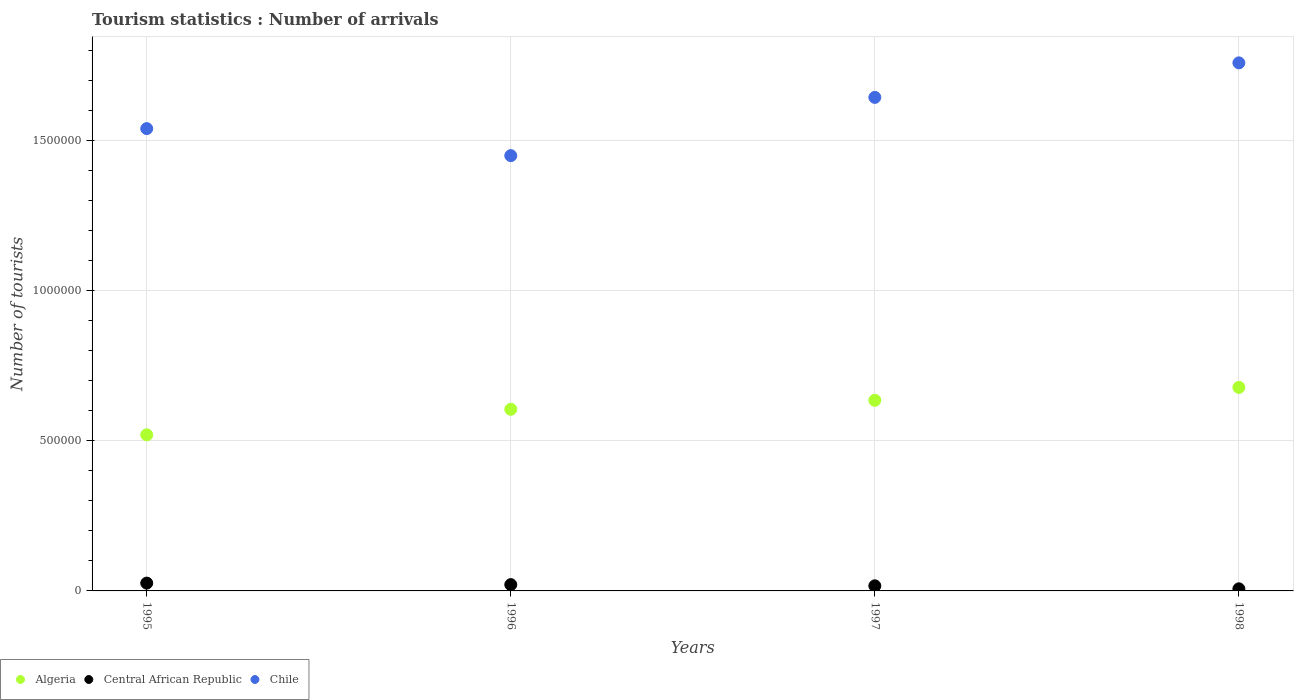What is the number of tourist arrivals in Algeria in 1996?
Make the answer very short. 6.05e+05. Across all years, what is the maximum number of tourist arrivals in Algeria?
Make the answer very short. 6.78e+05. Across all years, what is the minimum number of tourist arrivals in Central African Republic?
Offer a terse response. 7000. In which year was the number of tourist arrivals in Algeria minimum?
Your answer should be very brief. 1995. What is the total number of tourist arrivals in Central African Republic in the graph?
Offer a terse response. 7.10e+04. What is the difference between the number of tourist arrivals in Chile in 1996 and that in 1997?
Your answer should be very brief. -1.94e+05. What is the difference between the number of tourist arrivals in Chile in 1997 and the number of tourist arrivals in Central African Republic in 1996?
Your response must be concise. 1.62e+06. What is the average number of tourist arrivals in Algeria per year?
Your answer should be very brief. 6.10e+05. In the year 1995, what is the difference between the number of tourist arrivals in Chile and number of tourist arrivals in Algeria?
Your answer should be compact. 1.02e+06. In how many years, is the number of tourist arrivals in Chile greater than 600000?
Offer a very short reply. 4. What is the ratio of the number of tourist arrivals in Central African Republic in 1996 to that in 1998?
Provide a short and direct response. 3. Is the difference between the number of tourist arrivals in Chile in 1995 and 1996 greater than the difference between the number of tourist arrivals in Algeria in 1995 and 1996?
Keep it short and to the point. Yes. What is the difference between the highest and the second highest number of tourist arrivals in Chile?
Ensure brevity in your answer.  1.15e+05. What is the difference between the highest and the lowest number of tourist arrivals in Chile?
Give a very brief answer. 3.09e+05. Is the sum of the number of tourist arrivals in Algeria in 1997 and 1998 greater than the maximum number of tourist arrivals in Central African Republic across all years?
Ensure brevity in your answer.  Yes. Is it the case that in every year, the sum of the number of tourist arrivals in Central African Republic and number of tourist arrivals in Algeria  is greater than the number of tourist arrivals in Chile?
Your answer should be very brief. No. Does the number of tourist arrivals in Central African Republic monotonically increase over the years?
Your answer should be very brief. No. How many years are there in the graph?
Make the answer very short. 4. What is the difference between two consecutive major ticks on the Y-axis?
Offer a terse response. 5.00e+05. Does the graph contain grids?
Provide a succinct answer. Yes. Where does the legend appear in the graph?
Offer a terse response. Bottom left. What is the title of the graph?
Provide a succinct answer. Tourism statistics : Number of arrivals. What is the label or title of the X-axis?
Your response must be concise. Years. What is the label or title of the Y-axis?
Your response must be concise. Number of tourists. What is the Number of tourists of Algeria in 1995?
Offer a terse response. 5.20e+05. What is the Number of tourists of Central African Republic in 1995?
Your response must be concise. 2.60e+04. What is the Number of tourists in Chile in 1995?
Provide a succinct answer. 1.54e+06. What is the Number of tourists of Algeria in 1996?
Offer a terse response. 6.05e+05. What is the Number of tourists of Central African Republic in 1996?
Your response must be concise. 2.10e+04. What is the Number of tourists in Chile in 1996?
Your answer should be compact. 1.45e+06. What is the Number of tourists of Algeria in 1997?
Give a very brief answer. 6.35e+05. What is the Number of tourists of Central African Republic in 1997?
Your answer should be very brief. 1.70e+04. What is the Number of tourists in Chile in 1997?
Provide a succinct answer. 1.64e+06. What is the Number of tourists in Algeria in 1998?
Your answer should be very brief. 6.78e+05. What is the Number of tourists of Central African Republic in 1998?
Keep it short and to the point. 7000. What is the Number of tourists in Chile in 1998?
Provide a succinct answer. 1.76e+06. Across all years, what is the maximum Number of tourists of Algeria?
Ensure brevity in your answer.  6.78e+05. Across all years, what is the maximum Number of tourists of Central African Republic?
Provide a short and direct response. 2.60e+04. Across all years, what is the maximum Number of tourists in Chile?
Your response must be concise. 1.76e+06. Across all years, what is the minimum Number of tourists in Algeria?
Your response must be concise. 5.20e+05. Across all years, what is the minimum Number of tourists of Central African Republic?
Keep it short and to the point. 7000. Across all years, what is the minimum Number of tourists in Chile?
Keep it short and to the point. 1.45e+06. What is the total Number of tourists in Algeria in the graph?
Ensure brevity in your answer.  2.44e+06. What is the total Number of tourists of Central African Republic in the graph?
Provide a succinct answer. 7.10e+04. What is the total Number of tourists of Chile in the graph?
Your response must be concise. 6.39e+06. What is the difference between the Number of tourists in Algeria in 1995 and that in 1996?
Provide a succinct answer. -8.50e+04. What is the difference between the Number of tourists in Algeria in 1995 and that in 1997?
Ensure brevity in your answer.  -1.15e+05. What is the difference between the Number of tourists in Central African Republic in 1995 and that in 1997?
Your answer should be compact. 9000. What is the difference between the Number of tourists in Chile in 1995 and that in 1997?
Your response must be concise. -1.04e+05. What is the difference between the Number of tourists of Algeria in 1995 and that in 1998?
Your answer should be compact. -1.58e+05. What is the difference between the Number of tourists of Central African Republic in 1995 and that in 1998?
Give a very brief answer. 1.90e+04. What is the difference between the Number of tourists in Chile in 1995 and that in 1998?
Your answer should be very brief. -2.19e+05. What is the difference between the Number of tourists of Central African Republic in 1996 and that in 1997?
Give a very brief answer. 4000. What is the difference between the Number of tourists in Chile in 1996 and that in 1997?
Make the answer very short. -1.94e+05. What is the difference between the Number of tourists in Algeria in 1996 and that in 1998?
Give a very brief answer. -7.30e+04. What is the difference between the Number of tourists of Central African Republic in 1996 and that in 1998?
Keep it short and to the point. 1.40e+04. What is the difference between the Number of tourists of Chile in 1996 and that in 1998?
Keep it short and to the point. -3.09e+05. What is the difference between the Number of tourists in Algeria in 1997 and that in 1998?
Your answer should be very brief. -4.30e+04. What is the difference between the Number of tourists of Central African Republic in 1997 and that in 1998?
Ensure brevity in your answer.  10000. What is the difference between the Number of tourists in Chile in 1997 and that in 1998?
Provide a succinct answer. -1.15e+05. What is the difference between the Number of tourists in Algeria in 1995 and the Number of tourists in Central African Republic in 1996?
Offer a terse response. 4.99e+05. What is the difference between the Number of tourists in Algeria in 1995 and the Number of tourists in Chile in 1996?
Ensure brevity in your answer.  -9.30e+05. What is the difference between the Number of tourists in Central African Republic in 1995 and the Number of tourists in Chile in 1996?
Provide a short and direct response. -1.42e+06. What is the difference between the Number of tourists of Algeria in 1995 and the Number of tourists of Central African Republic in 1997?
Provide a short and direct response. 5.03e+05. What is the difference between the Number of tourists of Algeria in 1995 and the Number of tourists of Chile in 1997?
Make the answer very short. -1.12e+06. What is the difference between the Number of tourists in Central African Republic in 1995 and the Number of tourists in Chile in 1997?
Ensure brevity in your answer.  -1.62e+06. What is the difference between the Number of tourists of Algeria in 1995 and the Number of tourists of Central African Republic in 1998?
Your response must be concise. 5.13e+05. What is the difference between the Number of tourists in Algeria in 1995 and the Number of tourists in Chile in 1998?
Provide a succinct answer. -1.24e+06. What is the difference between the Number of tourists in Central African Republic in 1995 and the Number of tourists in Chile in 1998?
Your response must be concise. -1.73e+06. What is the difference between the Number of tourists in Algeria in 1996 and the Number of tourists in Central African Republic in 1997?
Keep it short and to the point. 5.88e+05. What is the difference between the Number of tourists of Algeria in 1996 and the Number of tourists of Chile in 1997?
Your answer should be compact. -1.04e+06. What is the difference between the Number of tourists in Central African Republic in 1996 and the Number of tourists in Chile in 1997?
Provide a succinct answer. -1.62e+06. What is the difference between the Number of tourists in Algeria in 1996 and the Number of tourists in Central African Republic in 1998?
Offer a terse response. 5.98e+05. What is the difference between the Number of tourists in Algeria in 1996 and the Number of tourists in Chile in 1998?
Your answer should be very brief. -1.15e+06. What is the difference between the Number of tourists of Central African Republic in 1996 and the Number of tourists of Chile in 1998?
Give a very brief answer. -1.74e+06. What is the difference between the Number of tourists in Algeria in 1997 and the Number of tourists in Central African Republic in 1998?
Provide a succinct answer. 6.28e+05. What is the difference between the Number of tourists of Algeria in 1997 and the Number of tourists of Chile in 1998?
Provide a succinct answer. -1.12e+06. What is the difference between the Number of tourists of Central African Republic in 1997 and the Number of tourists of Chile in 1998?
Ensure brevity in your answer.  -1.74e+06. What is the average Number of tourists of Algeria per year?
Offer a very short reply. 6.10e+05. What is the average Number of tourists in Central African Republic per year?
Keep it short and to the point. 1.78e+04. What is the average Number of tourists in Chile per year?
Provide a succinct answer. 1.60e+06. In the year 1995, what is the difference between the Number of tourists of Algeria and Number of tourists of Central African Republic?
Keep it short and to the point. 4.94e+05. In the year 1995, what is the difference between the Number of tourists of Algeria and Number of tourists of Chile?
Keep it short and to the point. -1.02e+06. In the year 1995, what is the difference between the Number of tourists in Central African Republic and Number of tourists in Chile?
Give a very brief answer. -1.51e+06. In the year 1996, what is the difference between the Number of tourists of Algeria and Number of tourists of Central African Republic?
Offer a terse response. 5.84e+05. In the year 1996, what is the difference between the Number of tourists in Algeria and Number of tourists in Chile?
Offer a terse response. -8.45e+05. In the year 1996, what is the difference between the Number of tourists of Central African Republic and Number of tourists of Chile?
Your response must be concise. -1.43e+06. In the year 1997, what is the difference between the Number of tourists in Algeria and Number of tourists in Central African Republic?
Your answer should be compact. 6.18e+05. In the year 1997, what is the difference between the Number of tourists of Algeria and Number of tourists of Chile?
Ensure brevity in your answer.  -1.01e+06. In the year 1997, what is the difference between the Number of tourists of Central African Republic and Number of tourists of Chile?
Give a very brief answer. -1.63e+06. In the year 1998, what is the difference between the Number of tourists in Algeria and Number of tourists in Central African Republic?
Give a very brief answer. 6.71e+05. In the year 1998, what is the difference between the Number of tourists of Algeria and Number of tourists of Chile?
Provide a succinct answer. -1.08e+06. In the year 1998, what is the difference between the Number of tourists of Central African Republic and Number of tourists of Chile?
Offer a very short reply. -1.75e+06. What is the ratio of the Number of tourists of Algeria in 1995 to that in 1996?
Provide a short and direct response. 0.86. What is the ratio of the Number of tourists of Central African Republic in 1995 to that in 1996?
Your answer should be compact. 1.24. What is the ratio of the Number of tourists of Chile in 1995 to that in 1996?
Make the answer very short. 1.06. What is the ratio of the Number of tourists in Algeria in 1995 to that in 1997?
Give a very brief answer. 0.82. What is the ratio of the Number of tourists of Central African Republic in 1995 to that in 1997?
Make the answer very short. 1.53. What is the ratio of the Number of tourists in Chile in 1995 to that in 1997?
Ensure brevity in your answer.  0.94. What is the ratio of the Number of tourists of Algeria in 1995 to that in 1998?
Offer a terse response. 0.77. What is the ratio of the Number of tourists in Central African Republic in 1995 to that in 1998?
Your answer should be very brief. 3.71. What is the ratio of the Number of tourists of Chile in 1995 to that in 1998?
Ensure brevity in your answer.  0.88. What is the ratio of the Number of tourists of Algeria in 1996 to that in 1997?
Your response must be concise. 0.95. What is the ratio of the Number of tourists of Central African Republic in 1996 to that in 1997?
Provide a succinct answer. 1.24. What is the ratio of the Number of tourists in Chile in 1996 to that in 1997?
Provide a succinct answer. 0.88. What is the ratio of the Number of tourists of Algeria in 1996 to that in 1998?
Offer a terse response. 0.89. What is the ratio of the Number of tourists in Central African Republic in 1996 to that in 1998?
Your response must be concise. 3. What is the ratio of the Number of tourists of Chile in 1996 to that in 1998?
Your answer should be compact. 0.82. What is the ratio of the Number of tourists of Algeria in 1997 to that in 1998?
Give a very brief answer. 0.94. What is the ratio of the Number of tourists in Central African Republic in 1997 to that in 1998?
Your response must be concise. 2.43. What is the ratio of the Number of tourists in Chile in 1997 to that in 1998?
Offer a terse response. 0.93. What is the difference between the highest and the second highest Number of tourists of Algeria?
Give a very brief answer. 4.30e+04. What is the difference between the highest and the second highest Number of tourists in Central African Republic?
Your response must be concise. 5000. What is the difference between the highest and the second highest Number of tourists in Chile?
Offer a terse response. 1.15e+05. What is the difference between the highest and the lowest Number of tourists of Algeria?
Offer a terse response. 1.58e+05. What is the difference between the highest and the lowest Number of tourists in Central African Republic?
Provide a succinct answer. 1.90e+04. What is the difference between the highest and the lowest Number of tourists of Chile?
Provide a succinct answer. 3.09e+05. 